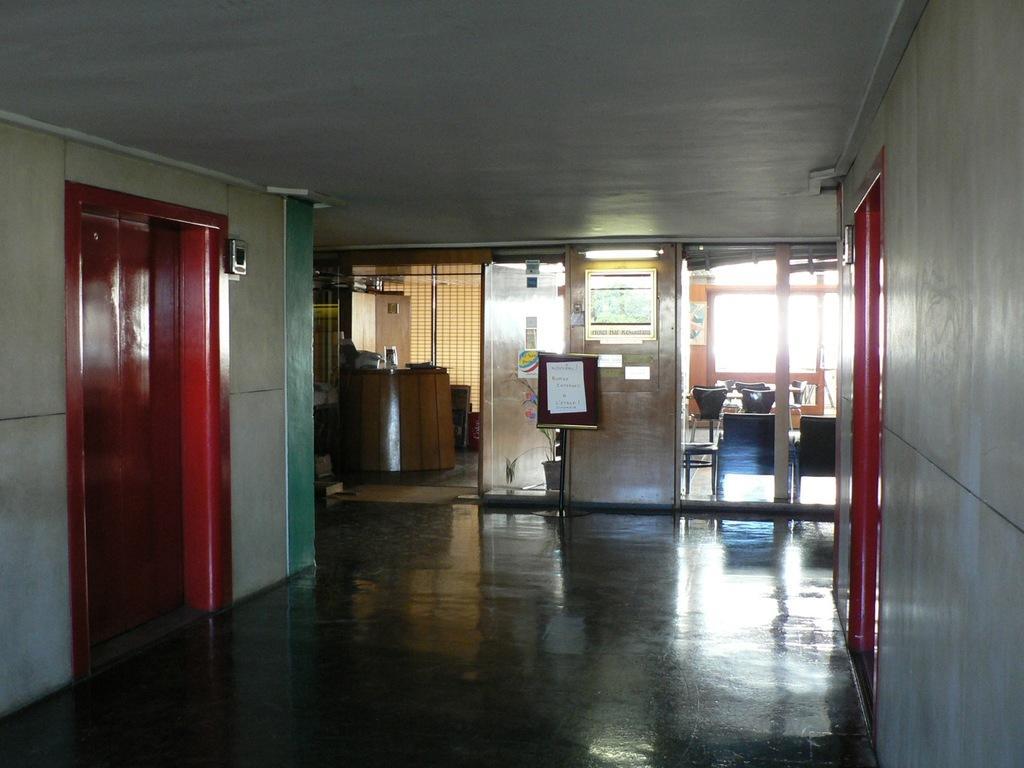How would you summarize this image in a sentence or two? As we can see in the image there are doors, chairs, posters, windows and white color wall. The image is little dark. There is a light and fence. 